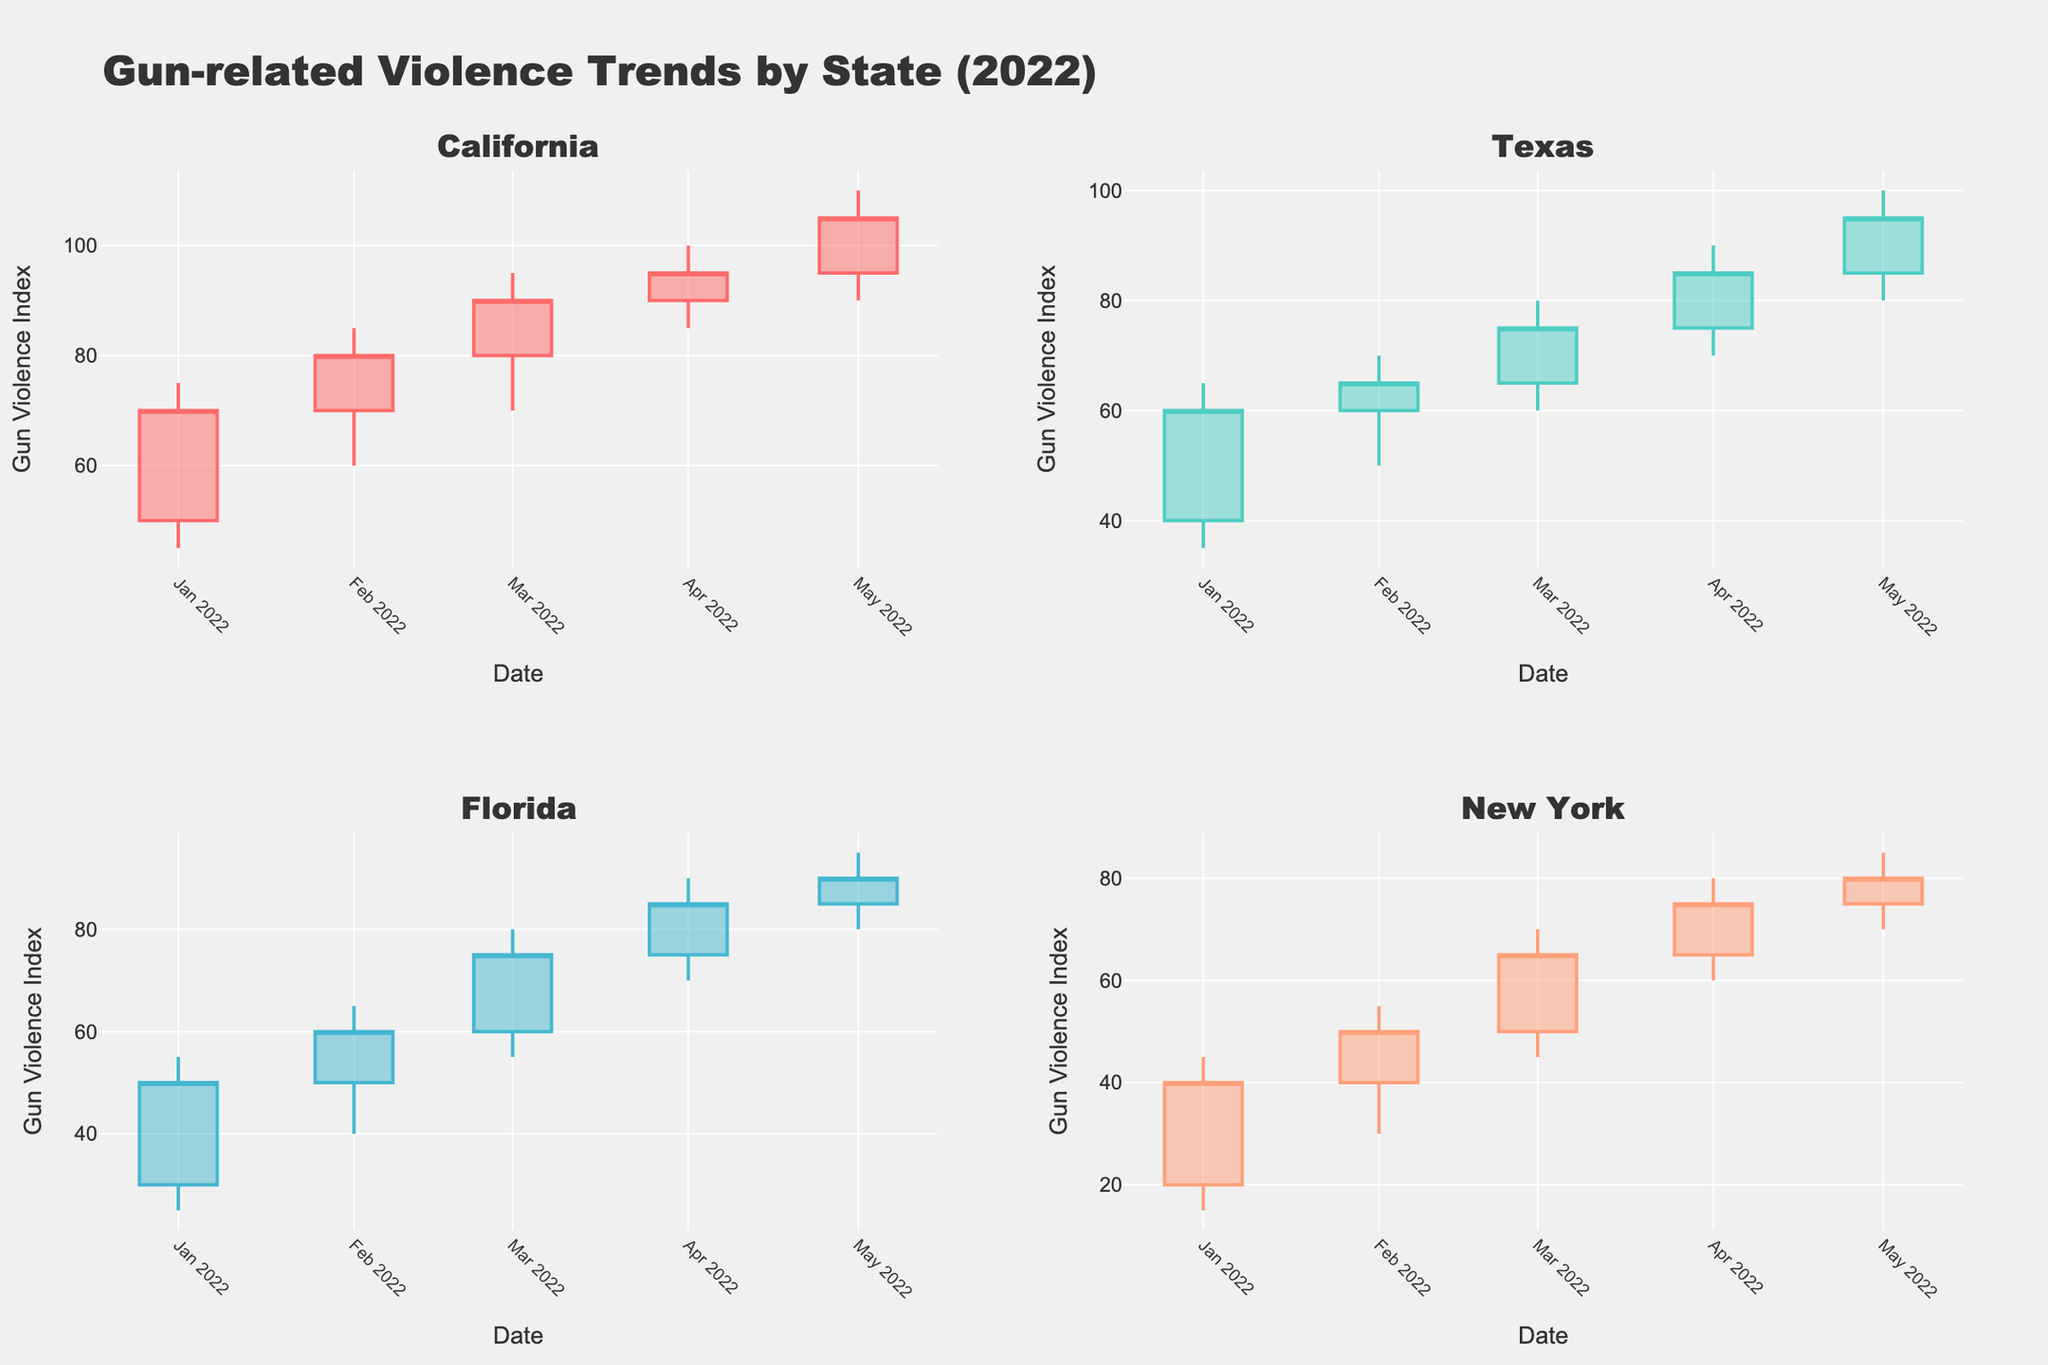What's the highest gun violence index recorded in California in 2022? The highest value for California in 2022 can be found by looking at the "High" values in the candlestick plot. The highest value is 110 in May 2022
Answer: 110 Which state saw an increase in gun violence index every month from January to May 2022? By examining the candlestick plot for each state, we can see that California's closing values increase in each month from January (70) to May (105)
Answer: California Is the trend of gun violence index in Texas increasing or decreasing over the given time period? By looking at the general direction of the closing values from January (60) to May (95), the trend is increasing
Answer: Increasing In April 2022, which state had the highest gun violence index? For April 2022, look at the "High" value in each state's candlestick. California has the highest value at 100
Answer: California Compare the initial and final gun violence index in Florida from January to May 2022. The "Open" value in January is 30, and the "Close" value in May is 90. So, it increased by 60 points (90 - 30)
Answer: 60 Which state had the smallest increase in the gun violence index from April to May 2022? Compare the difference between the closing values of April and May for each state: 
- California: 105 - 95 = 10 
- Texas: 95 - 85 = 10 
- Florida: 90 - 85 = 5 
- New York: 80 - 75 = 5
Both Florida and New York have the smallest increase of 5
Answer: Florida and New York What's the average closing gun violence index in New York for the given months? Add the closing values for New York (40, 50, 65, 75, 80) and divide by 5: (40 + 50 + 65 + 75 + 80) / 5 = 62
Answer: 62 Which state experienced the highest volatility in gun violence index in May 2022? Volatility is indicated by the range between "High" and "Low" values. For May, the ranges are:
- California: 110 - 90 = 20
- Texas: 100 - 80 = 20
- Florida: 95 - 80 = 15
- New York: 85 - 70 = 15
Both California and Texas have the highest volatility with a range of 20
Answer: California and Texas How does the trend in gun violence index in New York compare to Texas over the given period? Both states have an increasing trend in their closing values, but New York started lower (40 in Jan) and ended at 80 in May, while Texas started at 60 in Jan and ended at 95
Answer: Both increasing, Texas higher 